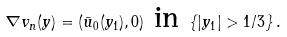<formula> <loc_0><loc_0><loc_500><loc_500>\nabla v _ { n } ( y ) = ( \bar { u } _ { 0 } ( y _ { 1 } ) , 0 ) \text { in } \{ | y _ { 1 } | > 1 / 3 \} \, .</formula> 